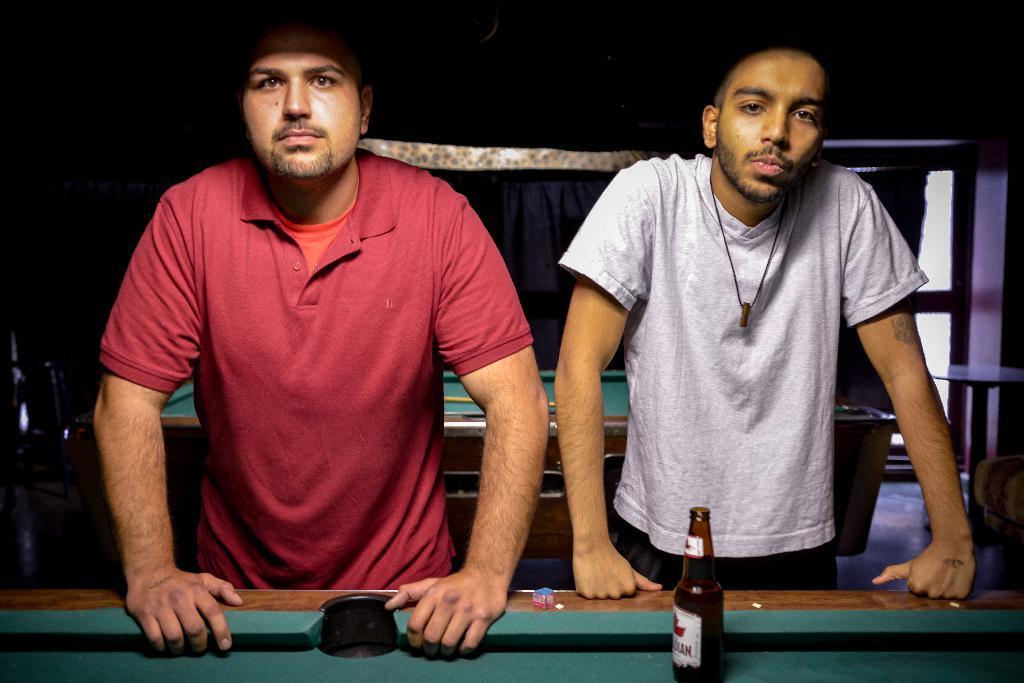How would you summarize this image in a sentence or two? There are two people standing. This looks like a snooker table which is green in color. I can see a beer bottle placed on the snooker table. At background I can see another snooker table. This looks like a stick placed on it. Here is a small table. This looks like a couch. Background I can see a door and this is the cloth hanging. 